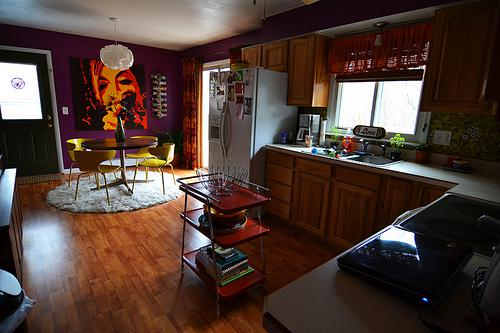Question: when is this?
Choices:
A. During the day.
B. Tomorrow.
C. On the weekend.
D. Next month.
Answer with the letter. Answer: A Question: what color is the wall?
Choices:
A. White.
B. Beige.
C. Yellow.
D. Purple.
Answer with the letter. Answer: D Question: what rooms are shown?
Choices:
A. Living room.
B. Bedroom.
C. Kitchen.
D. The kitchen and dining room.
Answer with the letter. Answer: D Question: where is the door?
Choices:
A. Down the hall.
B. In the front of the house.
C. Under the exit sign.
D. On the back wall.
Answer with the letter. Answer: D Question: where is this scene?
Choices:
A. At the mall.
B. At the park.
C. In the movie theatre.
D. In a house.
Answer with the letter. Answer: D Question: what color is the carpet?
Choices:
A. Brown.
B. Red.
C. Grey.
D. White.
Answer with the letter. Answer: D Question: how man chairs are there?
Choices:
A. Five.
B. Three.
C. Four.
D. Six.
Answer with the letter. Answer: C Question: where is the computer?
Choices:
A. On the computer desk.
B. In the computer room.
C. On the counter.
D. In the living room.
Answer with the letter. Answer: C 